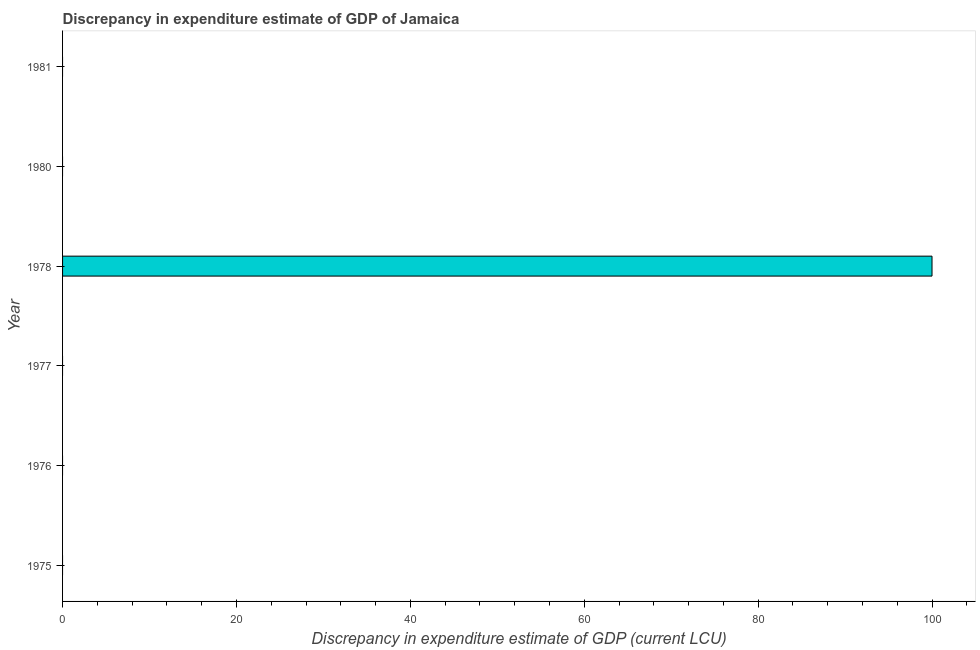What is the title of the graph?
Your response must be concise. Discrepancy in expenditure estimate of GDP of Jamaica. What is the label or title of the X-axis?
Your response must be concise. Discrepancy in expenditure estimate of GDP (current LCU). What is the label or title of the Y-axis?
Your response must be concise. Year. What is the discrepancy in expenditure estimate of gdp in 1977?
Ensure brevity in your answer.  0. Across all years, what is the maximum discrepancy in expenditure estimate of gdp?
Your answer should be compact. 100. Across all years, what is the minimum discrepancy in expenditure estimate of gdp?
Your answer should be compact. 0. In which year was the discrepancy in expenditure estimate of gdp maximum?
Your answer should be very brief. 1978. What is the sum of the discrepancy in expenditure estimate of gdp?
Your response must be concise. 100. What is the average discrepancy in expenditure estimate of gdp per year?
Ensure brevity in your answer.  16.67. In how many years, is the discrepancy in expenditure estimate of gdp greater than 56 LCU?
Your response must be concise. 1. What is the difference between the highest and the lowest discrepancy in expenditure estimate of gdp?
Offer a terse response. 100. How many bars are there?
Offer a very short reply. 1. Are all the bars in the graph horizontal?
Your answer should be very brief. Yes. What is the Discrepancy in expenditure estimate of GDP (current LCU) of 1977?
Offer a very short reply. 0. What is the Discrepancy in expenditure estimate of GDP (current LCU) in 1978?
Ensure brevity in your answer.  100. What is the Discrepancy in expenditure estimate of GDP (current LCU) of 1980?
Make the answer very short. 0. What is the Discrepancy in expenditure estimate of GDP (current LCU) of 1981?
Your answer should be compact. 0. 